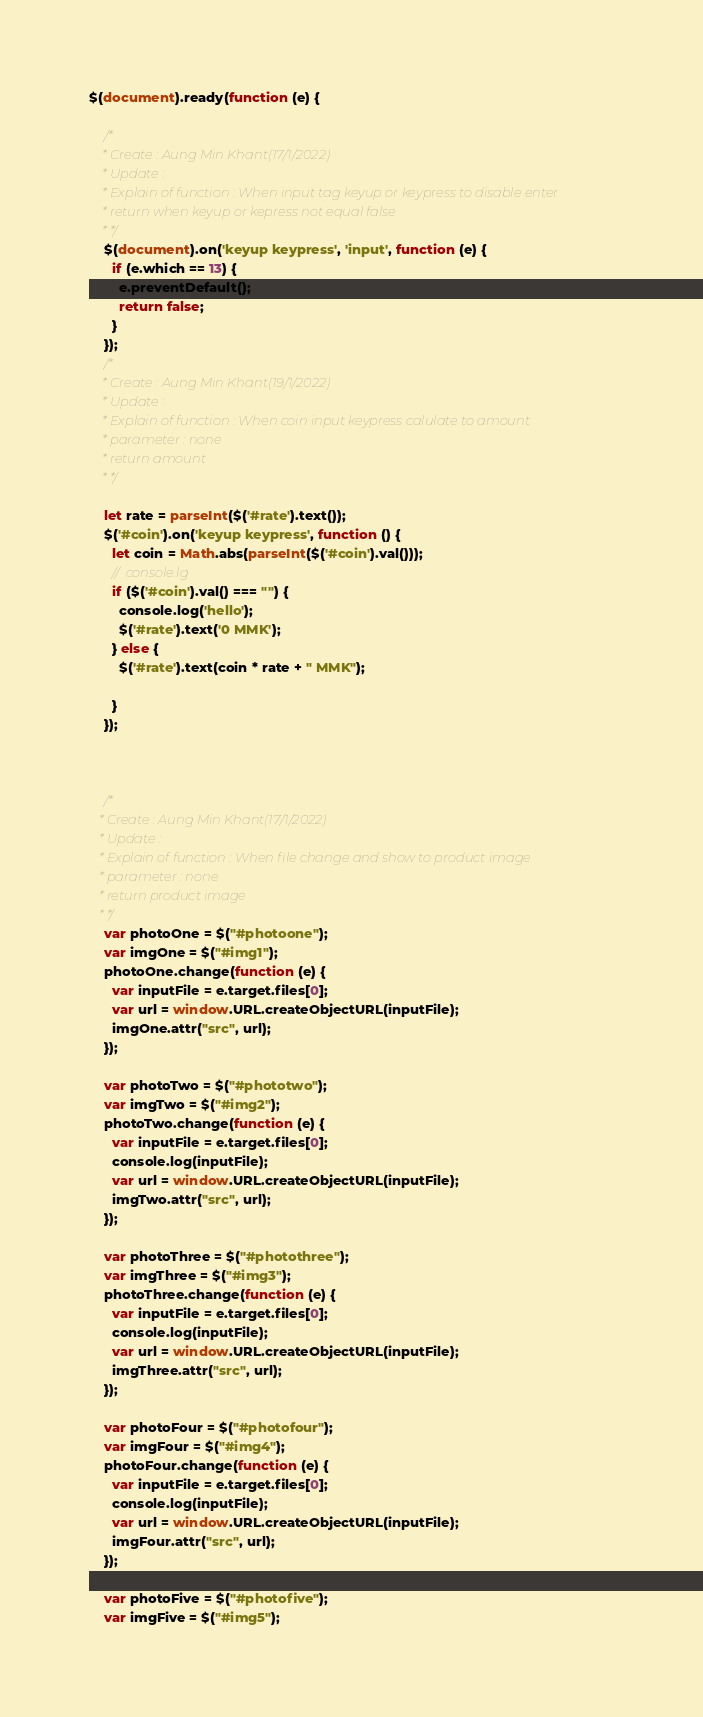Convert code to text. <code><loc_0><loc_0><loc_500><loc_500><_JavaScript_>
$(document).ready(function (e) {

    /*
    * Create : Aung Min Khant(17/1/2022)
    * Update :
    * Explain of function : When input tag keyup or keypress to disable enter 
    * return when keyup or kepress not equal false
    * */
    $(document).on('keyup keypress', 'input', function (e) {
      if (e.which == 13) {
        e.preventDefault();
        return false;
      }
    });
    /*
    * Create : Aung Min Khant(19/1/2022)
    * Update :
    * Explain of function : When coin input keypress calulate to amount
    * parameter : none 
    * return amount
    * */
  
    let rate = parseInt($('#rate').text());
    $('#coin').on('keyup keypress', function () {
      let coin = Math.abs(parseInt($('#coin').val()));
      //  console.lg
      if ($('#coin').val() === "") {
        console.log('hello');
        $('#rate').text('0 MMK');
      } else {
        $('#rate').text(coin * rate + " MMK");
  
      }
    });

  
  
    /*
   * Create : Aung Min Khant(17/1/2022)
   * Update :
   * Explain of function : When file change and show to product image  
   * parameter : none
   * return product image
   * */
    var photoOne = $("#photoone");
    var imgOne = $("#img1");
    photoOne.change(function (e) {
      var inputFile = e.target.files[0];
      var url = window.URL.createObjectURL(inputFile);
      imgOne.attr("src", url);
    });
  
    var photoTwo = $("#phototwo");
    var imgTwo = $("#img2");
    photoTwo.change(function (e) {
      var inputFile = e.target.files[0];
      console.log(inputFile);
      var url = window.URL.createObjectURL(inputFile);
      imgTwo.attr("src", url);
    });
  
    var photoThree = $("#photothree");
    var imgThree = $("#img3");
    photoThree.change(function (e) {
      var inputFile = e.target.files[0];
      console.log(inputFile);
      var url = window.URL.createObjectURL(inputFile);
      imgThree.attr("src", url);
    });
  
    var photoFour = $("#photofour");
    var imgFour = $("#img4");
    photoFour.change(function (e) {
      var inputFile = e.target.files[0];
      console.log(inputFile);
      var url = window.URL.createObjectURL(inputFile);
      imgFour.attr("src", url);
    });
  
    var photoFive = $("#photofive");
    var imgFive = $("#img5");</code> 